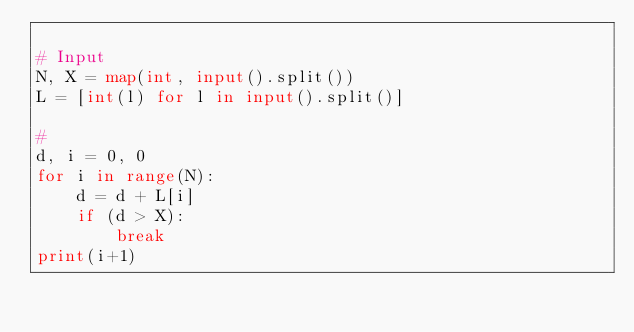Convert code to text. <code><loc_0><loc_0><loc_500><loc_500><_Python_>
# Input
N, X = map(int, input().split())
L = [int(l) for l in input().split()]

#
d, i = 0, 0
for i in range(N):
    d = d + L[i]
    if (d > X):        
        break
print(i+1)
</code> 